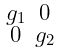<formula> <loc_0><loc_0><loc_500><loc_500>\begin{smallmatrix} g _ { 1 } & 0 \\ 0 & g _ { 2 } \end{smallmatrix}</formula> 